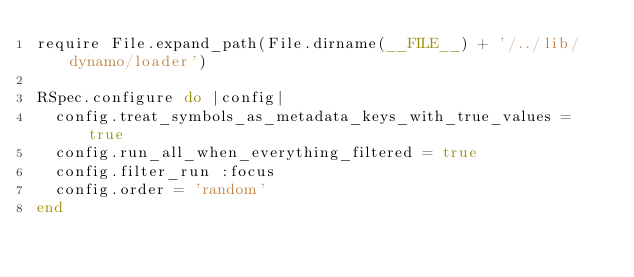Convert code to text. <code><loc_0><loc_0><loc_500><loc_500><_Ruby_>require File.expand_path(File.dirname(__FILE__) + '/../lib/dynamo/loader')

RSpec.configure do |config|
  config.treat_symbols_as_metadata_keys_with_true_values = true
  config.run_all_when_everything_filtered = true
  config.filter_run :focus
  config.order = 'random'
end
</code> 